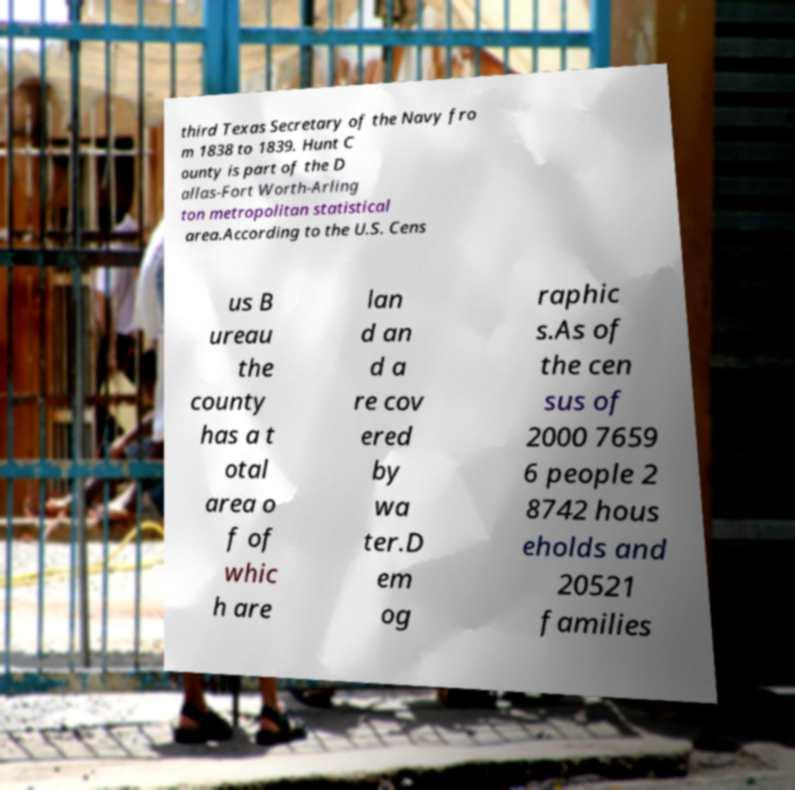I need the written content from this picture converted into text. Can you do that? third Texas Secretary of the Navy fro m 1838 to 1839. Hunt C ounty is part of the D allas-Fort Worth-Arling ton metropolitan statistical area.According to the U.S. Cens us B ureau the county has a t otal area o f of whic h are lan d an d a re cov ered by wa ter.D em og raphic s.As of the cen sus of 2000 7659 6 people 2 8742 hous eholds and 20521 families 